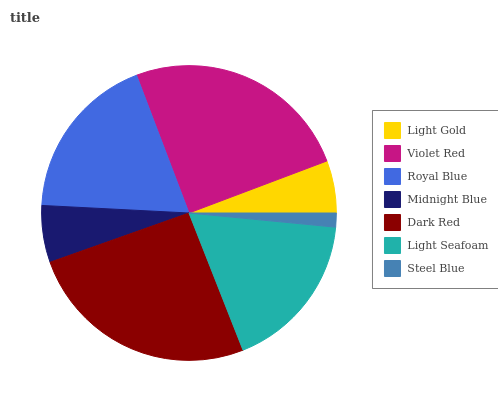Is Steel Blue the minimum?
Answer yes or no. Yes. Is Dark Red the maximum?
Answer yes or no. Yes. Is Violet Red the minimum?
Answer yes or no. No. Is Violet Red the maximum?
Answer yes or no. No. Is Violet Red greater than Light Gold?
Answer yes or no. Yes. Is Light Gold less than Violet Red?
Answer yes or no. Yes. Is Light Gold greater than Violet Red?
Answer yes or no. No. Is Violet Red less than Light Gold?
Answer yes or no. No. Is Light Seafoam the high median?
Answer yes or no. Yes. Is Light Seafoam the low median?
Answer yes or no. Yes. Is Steel Blue the high median?
Answer yes or no. No. Is Dark Red the low median?
Answer yes or no. No. 